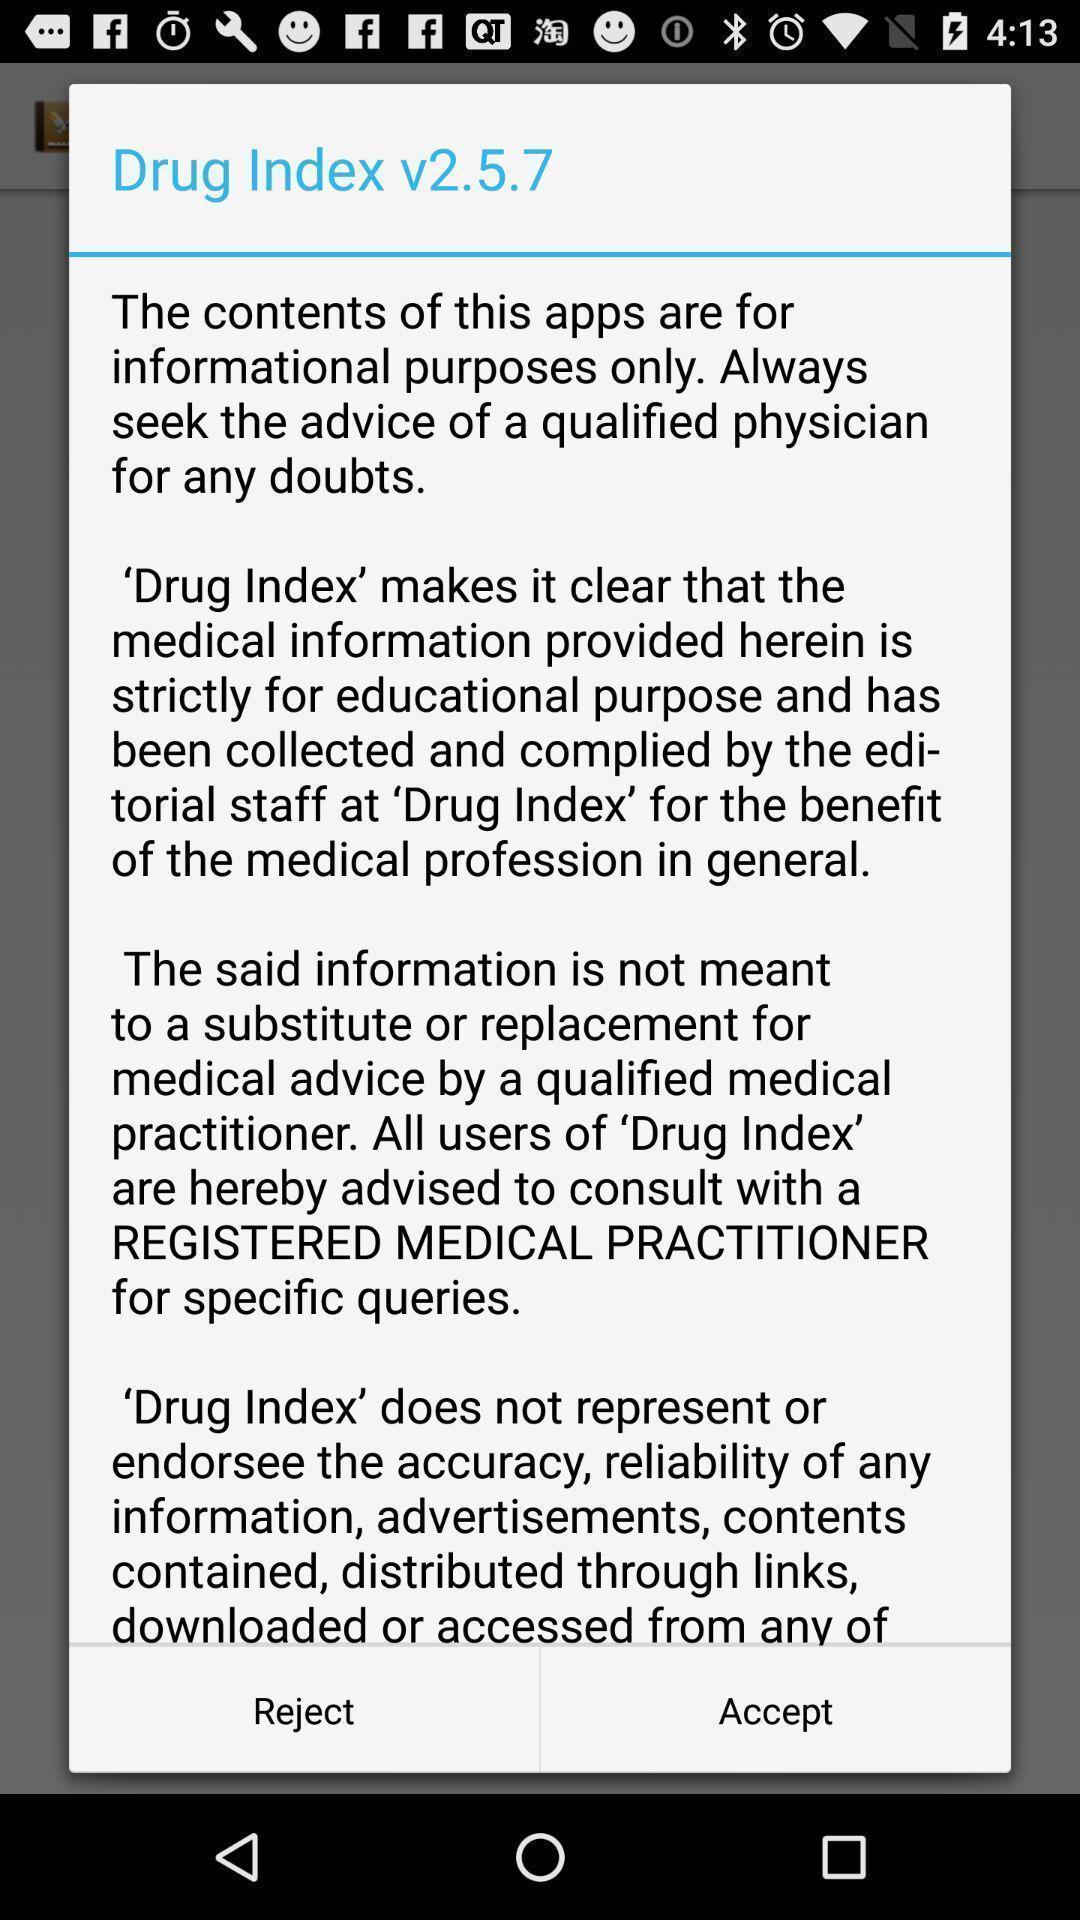Describe the content in this image. Pop up of app information with options. 